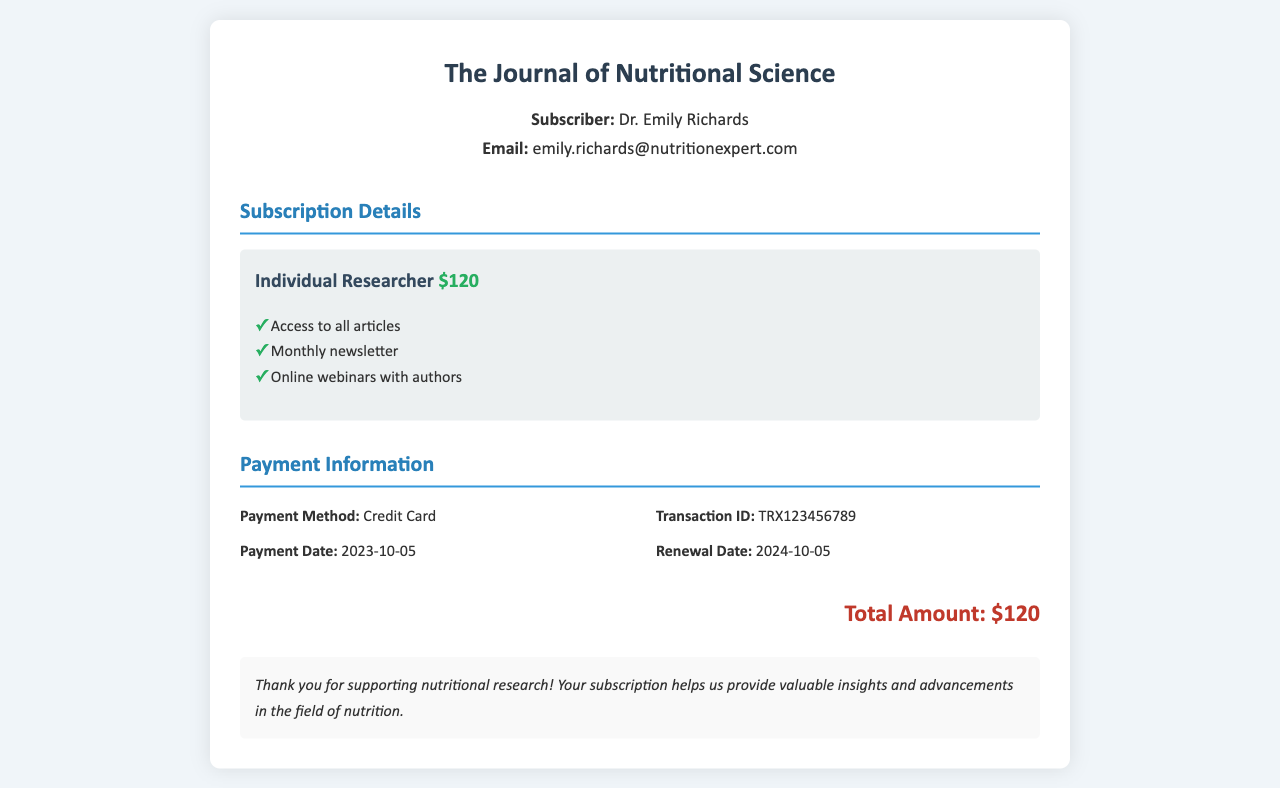What is the name of the journal? The journal name is clearly stated at the top of the receipt as "The Journal of Nutritional Science."
Answer: The Journal of Nutritional Science Who is the subscriber? The subscriber's name is provided in the subscriber info section, identifying them as Dr. Emily Richards.
Answer: Dr. Emily Richards What is the renewal date of the subscription? The renewal date is specified in the payment information section as the date when the subscription needs renewal.
Answer: 2024-10-05 What is the total amount paid for the subscription? The total amount is calculated and displayed at the end of the receipt as the sum for subscription access.
Answer: $120 What features are included in the Individual Researcher tier? The features included in the tier are listed under the specific tier information.
Answer: Access to all articles, Monthly newsletter, Online webinars with authors What payment method was used? The payment method is indicated in the payment information section, detailing how the transaction was carried out.
Answer: Credit Card What is the transaction ID? The transaction ID helps identify the specific payment made and is listed in the payment information section.
Answer: TRX123456789 What date was the payment made? The payment date indicates when the actual transaction occurred and is provided in the payment information section.
Answer: 2023-10-05 What is the significance of the subscription according to the notes? The notes reflect the appreciation towards the subscriber's support for nutritional research and its impact.
Answer: Supporting nutritional research 